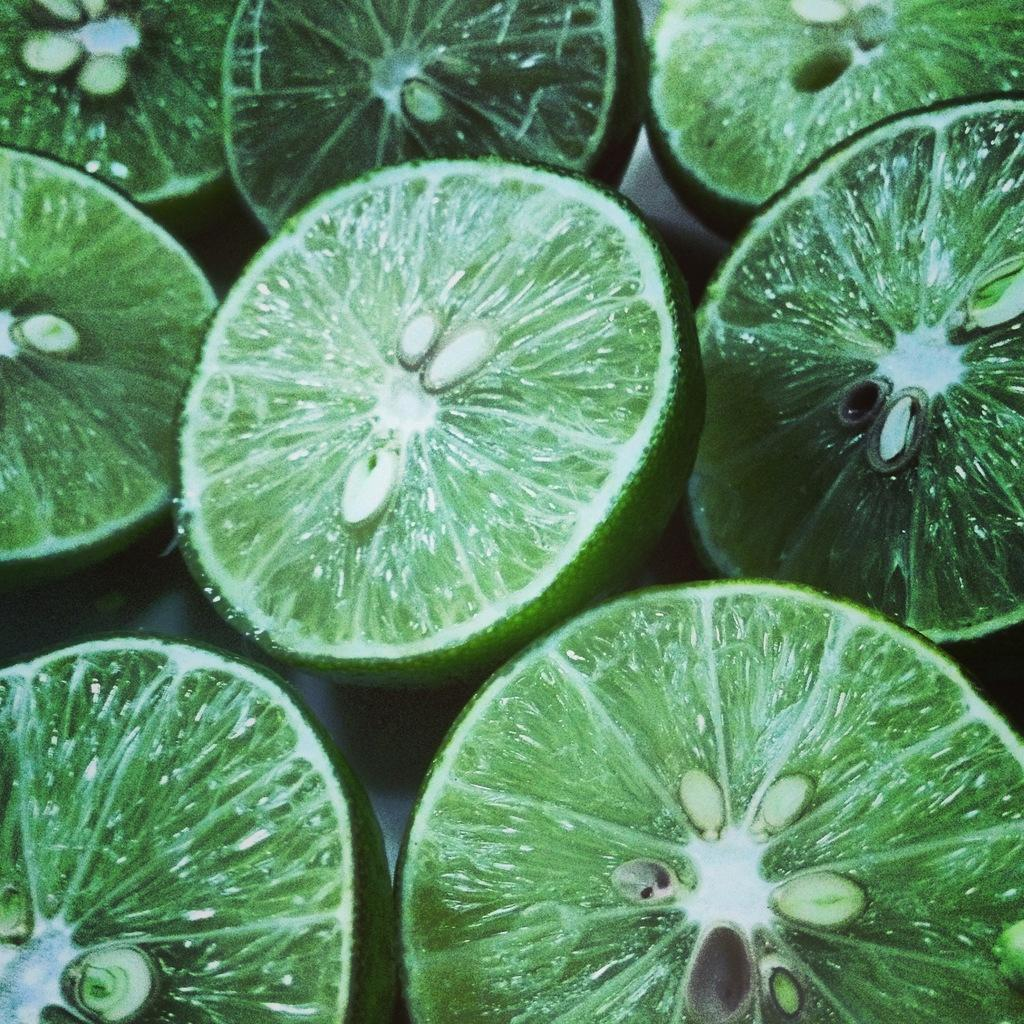What type of fruit is depicted in the image? The image contains lemon slices. Can you describe any specific features of the lemon slices? The lemon slices have seeds. What statement is being made by the lemon slices in the image? The lemon slices are not making a statement in the image; they are simply depicted as slices with seeds. 